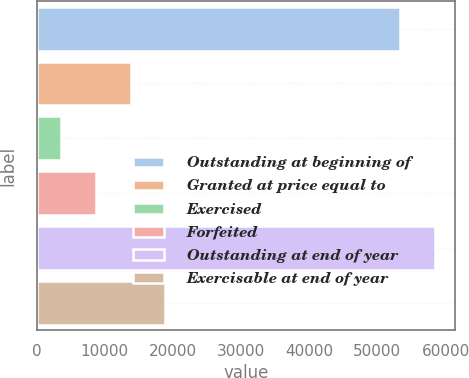<chart> <loc_0><loc_0><loc_500><loc_500><bar_chart><fcel>Outstanding at beginning of<fcel>Granted at price equal to<fcel>Exercised<fcel>Forfeited<fcel>Outstanding at end of year<fcel>Exercisable at end of year<nl><fcel>53358<fcel>13798.4<fcel>3635<fcel>8716.7<fcel>58439.7<fcel>18880.1<nl></chart> 